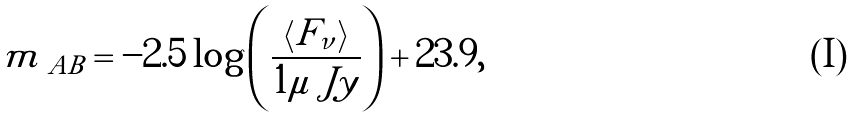Convert formula to latex. <formula><loc_0><loc_0><loc_500><loc_500>m _ { \ A B } = - 2 . 5 \log \left ( \frac { \left < F _ { \nu } \right > } { 1 \mu \ J y } \right ) + 2 3 . 9 ,</formula> 